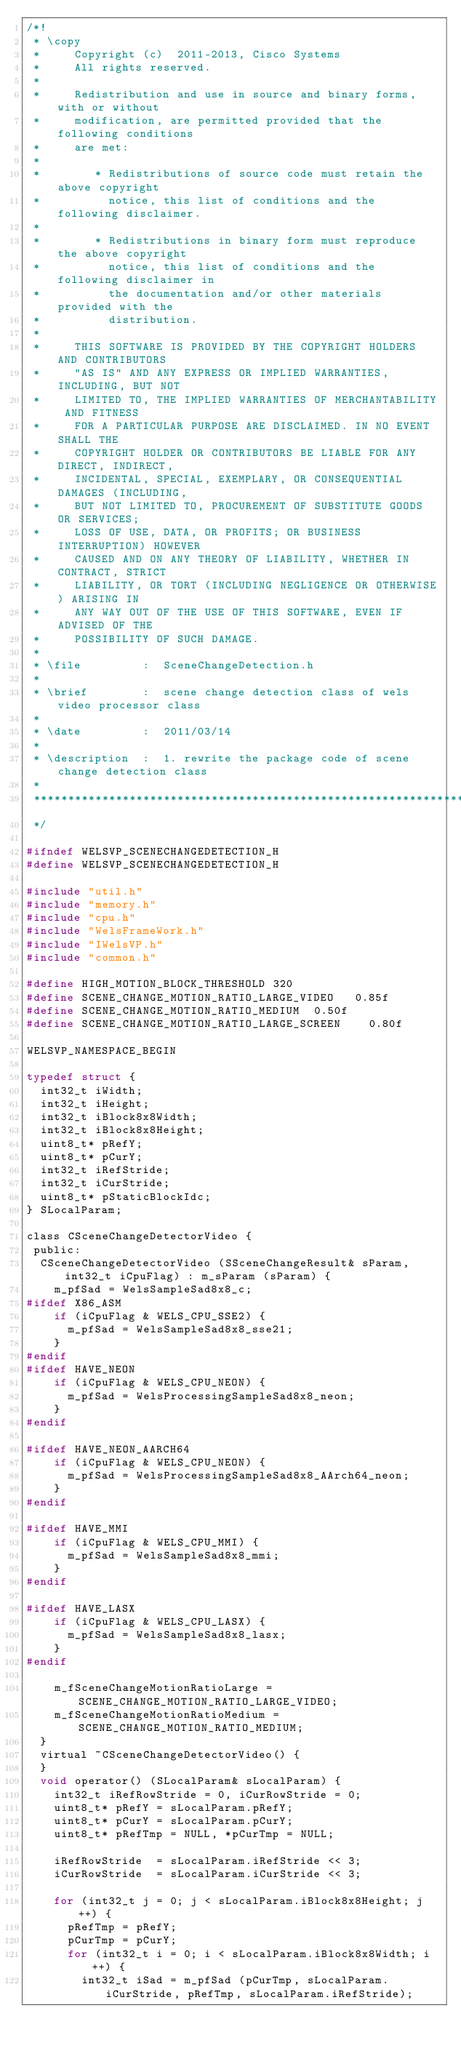<code> <loc_0><loc_0><loc_500><loc_500><_C_>/*!
 * \copy
 *     Copyright (c)  2011-2013, Cisco Systems
 *     All rights reserved.
 *
 *     Redistribution and use in source and binary forms, with or without
 *     modification, are permitted provided that the following conditions
 *     are met:
 *
 *        * Redistributions of source code must retain the above copyright
 *          notice, this list of conditions and the following disclaimer.
 *
 *        * Redistributions in binary form must reproduce the above copyright
 *          notice, this list of conditions and the following disclaimer in
 *          the documentation and/or other materials provided with the
 *          distribution.
 *
 *     THIS SOFTWARE IS PROVIDED BY THE COPYRIGHT HOLDERS AND CONTRIBUTORS
 *     "AS IS" AND ANY EXPRESS OR IMPLIED WARRANTIES, INCLUDING, BUT NOT
 *     LIMITED TO, THE IMPLIED WARRANTIES OF MERCHANTABILITY AND FITNESS
 *     FOR A PARTICULAR PURPOSE ARE DISCLAIMED. IN NO EVENT SHALL THE
 *     COPYRIGHT HOLDER OR CONTRIBUTORS BE LIABLE FOR ANY DIRECT, INDIRECT,
 *     INCIDENTAL, SPECIAL, EXEMPLARY, OR CONSEQUENTIAL DAMAGES (INCLUDING,
 *     BUT NOT LIMITED TO, PROCUREMENT OF SUBSTITUTE GOODS OR SERVICES;
 *     LOSS OF USE, DATA, OR PROFITS; OR BUSINESS INTERRUPTION) HOWEVER
 *     CAUSED AND ON ANY THEORY OF LIABILITY, WHETHER IN CONTRACT, STRICT
 *     LIABILITY, OR TORT (INCLUDING NEGLIGENCE OR OTHERWISE) ARISING IN
 *     ANY WAY OUT OF THE USE OF THIS SOFTWARE, EVEN IF ADVISED OF THE
 *     POSSIBILITY OF SUCH DAMAGE.
 *
 * \file         :  SceneChangeDetection.h
 *
 * \brief        :  scene change detection class of wels video processor class
 *
 * \date         :  2011/03/14
 *
 * \description  :  1. rewrite the package code of scene change detection class
 *
 *************************************************************************************
 */

#ifndef WELSVP_SCENECHANGEDETECTION_H
#define WELSVP_SCENECHANGEDETECTION_H

#include "util.h"
#include "memory.h"
#include "cpu.h"
#include "WelsFrameWork.h"
#include "IWelsVP.h"
#include "common.h"

#define HIGH_MOTION_BLOCK_THRESHOLD 320
#define SCENE_CHANGE_MOTION_RATIO_LARGE_VIDEO   0.85f
#define SCENE_CHANGE_MOTION_RATIO_MEDIUM  0.50f
#define SCENE_CHANGE_MOTION_RATIO_LARGE_SCREEN    0.80f

WELSVP_NAMESPACE_BEGIN

typedef struct {
  int32_t iWidth;
  int32_t iHeight;
  int32_t iBlock8x8Width;
  int32_t iBlock8x8Height;
  uint8_t* pRefY;
  uint8_t* pCurY;
  int32_t iRefStride;
  int32_t iCurStride;
  uint8_t* pStaticBlockIdc;
} SLocalParam;

class CSceneChangeDetectorVideo {
 public:
  CSceneChangeDetectorVideo (SSceneChangeResult& sParam, int32_t iCpuFlag) : m_sParam (sParam) {
    m_pfSad = WelsSampleSad8x8_c;
#ifdef X86_ASM
    if (iCpuFlag & WELS_CPU_SSE2) {
      m_pfSad = WelsSampleSad8x8_sse21;
    }
#endif
#ifdef HAVE_NEON
    if (iCpuFlag & WELS_CPU_NEON) {
      m_pfSad = WelsProcessingSampleSad8x8_neon;
    }
#endif

#ifdef HAVE_NEON_AARCH64
    if (iCpuFlag & WELS_CPU_NEON) {
      m_pfSad = WelsProcessingSampleSad8x8_AArch64_neon;
    }
#endif

#ifdef HAVE_MMI
    if (iCpuFlag & WELS_CPU_MMI) {
      m_pfSad = WelsSampleSad8x8_mmi;
    }
#endif

#ifdef HAVE_LASX
    if (iCpuFlag & WELS_CPU_LASX) {
      m_pfSad = WelsSampleSad8x8_lasx;
    }
#endif

    m_fSceneChangeMotionRatioLarge = SCENE_CHANGE_MOTION_RATIO_LARGE_VIDEO;
    m_fSceneChangeMotionRatioMedium = SCENE_CHANGE_MOTION_RATIO_MEDIUM;
  }
  virtual ~CSceneChangeDetectorVideo() {
  }
  void operator() (SLocalParam& sLocalParam) {
    int32_t iRefRowStride = 0, iCurRowStride = 0;
    uint8_t* pRefY = sLocalParam.pRefY;
    uint8_t* pCurY = sLocalParam.pCurY;
    uint8_t* pRefTmp = NULL, *pCurTmp = NULL;

    iRefRowStride  = sLocalParam.iRefStride << 3;
    iCurRowStride  = sLocalParam.iCurStride << 3;

    for (int32_t j = 0; j < sLocalParam.iBlock8x8Height; j++) {
      pRefTmp = pRefY;
      pCurTmp = pCurY;
      for (int32_t i = 0; i < sLocalParam.iBlock8x8Width; i++) {
        int32_t iSad = m_pfSad (pCurTmp, sLocalParam.iCurStride, pRefTmp, sLocalParam.iRefStride);</code> 